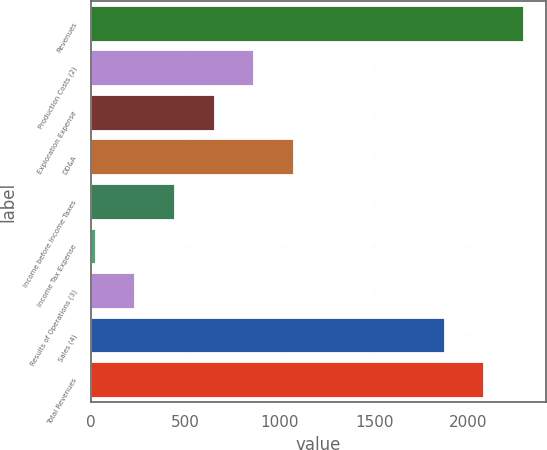Convert chart. <chart><loc_0><loc_0><loc_500><loc_500><bar_chart><fcel>Revenues<fcel>Production Costs (2)<fcel>Exploration Expense<fcel>DD&A<fcel>Income before Income Taxes<fcel>Income Tax Expense<fcel>Results of Operations (3)<fcel>Sales (4)<fcel>Total Revenues<nl><fcel>2294<fcel>864<fcel>654<fcel>1074<fcel>444<fcel>24<fcel>234<fcel>1874<fcel>2084<nl></chart> 